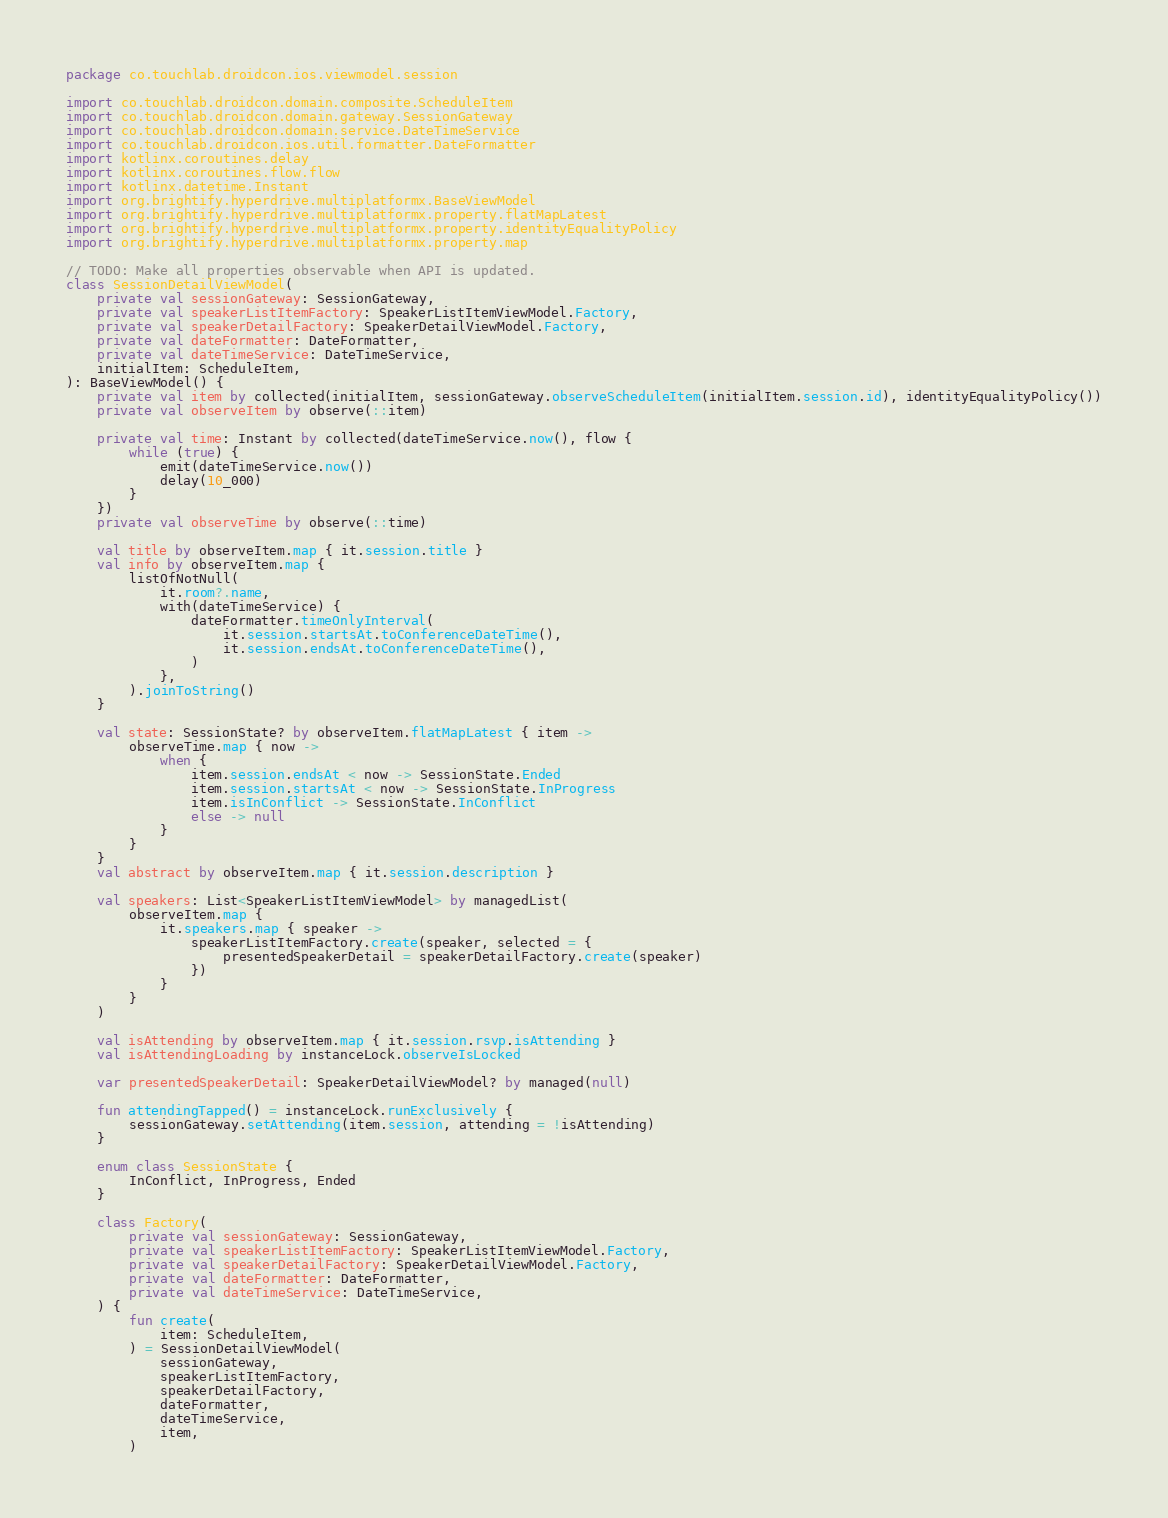Convert code to text. <code><loc_0><loc_0><loc_500><loc_500><_Kotlin_>package co.touchlab.droidcon.ios.viewmodel.session

import co.touchlab.droidcon.domain.composite.ScheduleItem
import co.touchlab.droidcon.domain.gateway.SessionGateway
import co.touchlab.droidcon.domain.service.DateTimeService
import co.touchlab.droidcon.ios.util.formatter.DateFormatter
import kotlinx.coroutines.delay
import kotlinx.coroutines.flow.flow
import kotlinx.datetime.Instant
import org.brightify.hyperdrive.multiplatformx.BaseViewModel
import org.brightify.hyperdrive.multiplatformx.property.flatMapLatest
import org.brightify.hyperdrive.multiplatformx.property.identityEqualityPolicy
import org.brightify.hyperdrive.multiplatformx.property.map

// TODO: Make all properties observable when API is updated.
class SessionDetailViewModel(
    private val sessionGateway: SessionGateway,
    private val speakerListItemFactory: SpeakerListItemViewModel.Factory,
    private val speakerDetailFactory: SpeakerDetailViewModel.Factory,
    private val dateFormatter: DateFormatter,
    private val dateTimeService: DateTimeService,
    initialItem: ScheduleItem,
): BaseViewModel() {
    private val item by collected(initialItem, sessionGateway.observeScheduleItem(initialItem.session.id), identityEqualityPolicy())
    private val observeItem by observe(::item)

    private val time: Instant by collected(dateTimeService.now(), flow {
        while (true) {
            emit(dateTimeService.now())
            delay(10_000)
        }
    })
    private val observeTime by observe(::time)

    val title by observeItem.map { it.session.title }
    val info by observeItem.map {
        listOfNotNull(
            it.room?.name,
            with(dateTimeService) {
                dateFormatter.timeOnlyInterval(
                    it.session.startsAt.toConferenceDateTime(),
                    it.session.endsAt.toConferenceDateTime(),
                )
            },
        ).joinToString()
    }

    val state: SessionState? by observeItem.flatMapLatest { item ->
        observeTime.map { now ->
            when {
                item.session.endsAt < now -> SessionState.Ended
                item.session.startsAt < now -> SessionState.InProgress
                item.isInConflict -> SessionState.InConflict
                else -> null
            }
        }
    }
    val abstract by observeItem.map { it.session.description }

    val speakers: List<SpeakerListItemViewModel> by managedList(
        observeItem.map {
            it.speakers.map { speaker ->
                speakerListItemFactory.create(speaker, selected = {
                    presentedSpeakerDetail = speakerDetailFactory.create(speaker)
                })
            }
        }
    )

    val isAttending by observeItem.map { it.session.rsvp.isAttending }
    val isAttendingLoading by instanceLock.observeIsLocked

    var presentedSpeakerDetail: SpeakerDetailViewModel? by managed(null)

    fun attendingTapped() = instanceLock.runExclusively {
        sessionGateway.setAttending(item.session, attending = !isAttending)
    }

    enum class SessionState {
        InConflict, InProgress, Ended
    }

    class Factory(
        private val sessionGateway: SessionGateway,
        private val speakerListItemFactory: SpeakerListItemViewModel.Factory,
        private val speakerDetailFactory: SpeakerDetailViewModel.Factory,
        private val dateFormatter: DateFormatter,
        private val dateTimeService: DateTimeService,
    ) {
        fun create(
            item: ScheduleItem,
        ) = SessionDetailViewModel(
            sessionGateway,
            speakerListItemFactory,
            speakerDetailFactory,
            dateFormatter,
            dateTimeService,
            item,
        )</code> 